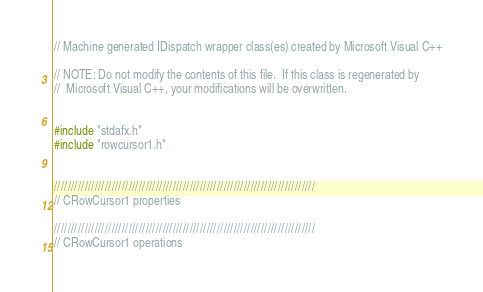<code> <loc_0><loc_0><loc_500><loc_500><_C++_>// Machine generated IDispatch wrapper class(es) created by Microsoft Visual C++

// NOTE: Do not modify the contents of this file.  If this class is regenerated by
//  Microsoft Visual C++, your modifications will be overwritten.


#include "stdafx.h"
#include "rowcursor1.h"


/////////////////////////////////////////////////////////////////////////////
// CRowCursor1 properties

/////////////////////////////////////////////////////////////////////////////
// CRowCursor1 operations
</code> 